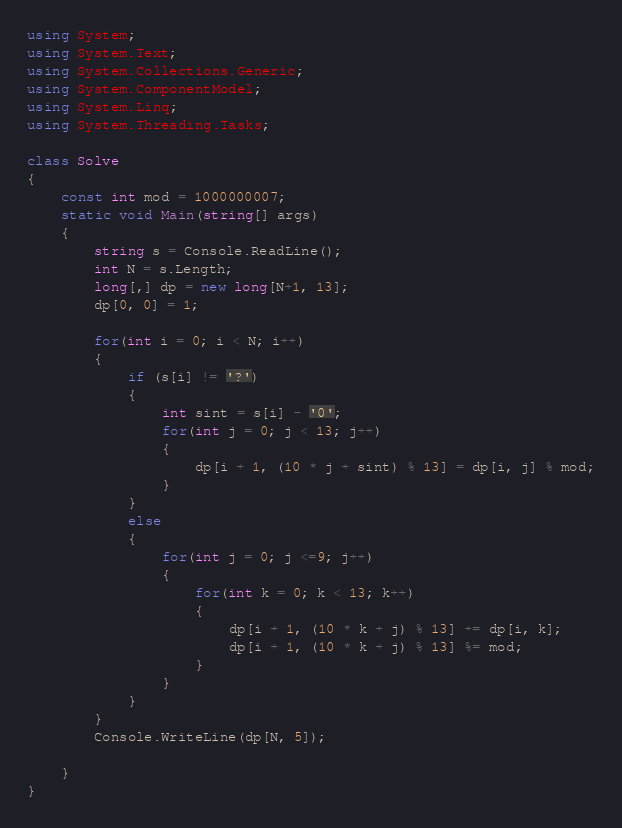Convert code to text. <code><loc_0><loc_0><loc_500><loc_500><_C#_>using System;
using System.Text;
using System.Collections.Generic;
using System.ComponentModel;
using System.Linq;
using System.Threading.Tasks;

class Solve
{
	const int mod = 1000000007;
	static void Main(string[] args)
	{
		string s = Console.ReadLine();
		int N = s.Length;
		long[,] dp = new long[N+1, 13];
		dp[0, 0] = 1;

        for(int i = 0; i < N; i++)
		{
			if (s[i] != '?')
			{
				int sint = s[i] - '0';
                for(int j = 0; j < 13; j++)
				{
					dp[i + 1, (10 * j + sint) % 13] = dp[i, j] % mod;
				}
			}
			else
			{
                for(int j = 0; j <=9; j++)
				{
                    for(int k = 0; k < 13; k++)
					{
						dp[i + 1, (10 * k + j) % 13] += dp[i, k];
						dp[i + 1, (10 * k + j) % 13] %= mod;
					}
				}
			}
		}
		Console.WriteLine(dp[N, 5]);

	}
}</code> 